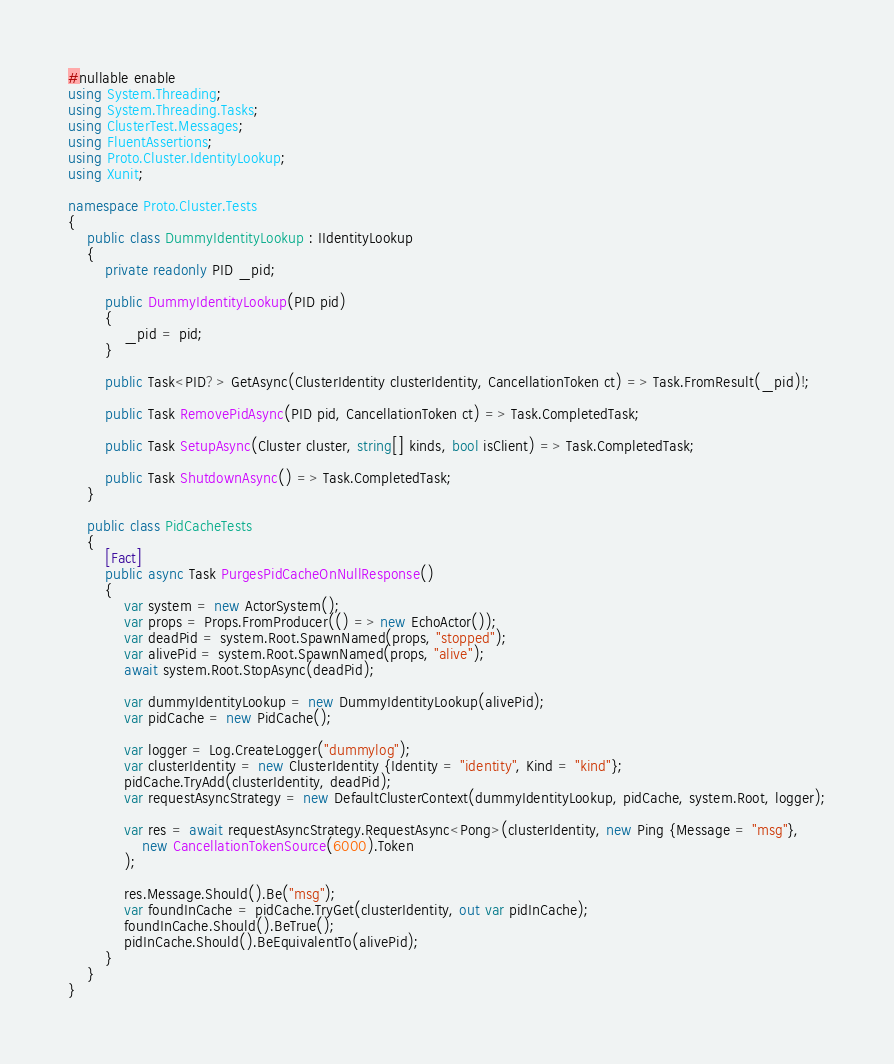Convert code to text. <code><loc_0><loc_0><loc_500><loc_500><_C#_>#nullable enable
using System.Threading;
using System.Threading.Tasks;
using ClusterTest.Messages;
using FluentAssertions;
using Proto.Cluster.IdentityLookup;
using Xunit;

namespace Proto.Cluster.Tests
{
    public class DummyIdentityLookup : IIdentityLookup
    {
        private readonly PID _pid;

        public DummyIdentityLookup(PID pid)
        {
            _pid = pid;
        }

        public Task<PID?> GetAsync(ClusterIdentity clusterIdentity, CancellationToken ct) => Task.FromResult(_pid)!;

        public Task RemovePidAsync(PID pid, CancellationToken ct) => Task.CompletedTask;

        public Task SetupAsync(Cluster cluster, string[] kinds, bool isClient) => Task.CompletedTask;

        public Task ShutdownAsync() => Task.CompletedTask;
    }

    public class PidCacheTests
    {
        [Fact]
        public async Task PurgesPidCacheOnNullResponse()
        {
            var system = new ActorSystem();
            var props = Props.FromProducer(() => new EchoActor());
            var deadPid = system.Root.SpawnNamed(props, "stopped");
            var alivePid = system.Root.SpawnNamed(props, "alive");
            await system.Root.StopAsync(deadPid);

            var dummyIdentityLookup = new DummyIdentityLookup(alivePid);
            var pidCache = new PidCache();

            var logger = Log.CreateLogger("dummylog");
            var clusterIdentity = new ClusterIdentity {Identity = "identity", Kind = "kind"};
            pidCache.TryAdd(clusterIdentity, deadPid);
            var requestAsyncStrategy = new DefaultClusterContext(dummyIdentityLookup, pidCache, system.Root, logger);

            var res = await requestAsyncStrategy.RequestAsync<Pong>(clusterIdentity, new Ping {Message = "msg"},
                new CancellationTokenSource(6000).Token
            );

            res.Message.Should().Be("msg");
            var foundInCache = pidCache.TryGet(clusterIdentity, out var pidInCache);
            foundInCache.Should().BeTrue();
            pidInCache.Should().BeEquivalentTo(alivePid);
        }
    }
}</code> 